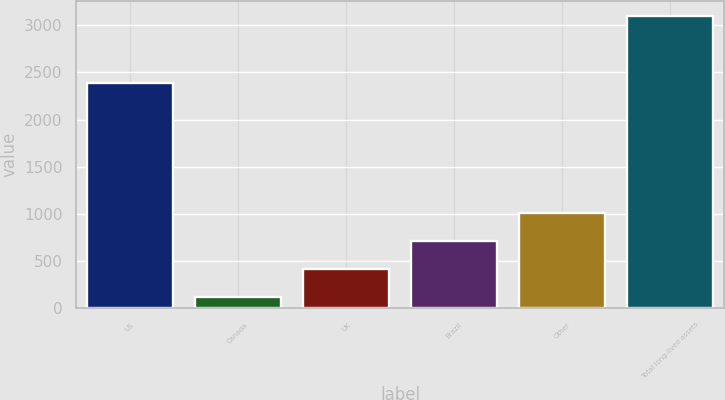Convert chart. <chart><loc_0><loc_0><loc_500><loc_500><bar_chart><fcel>US<fcel>Canada<fcel>UK<fcel>Brazil<fcel>Other<fcel>Total long-lived assets<nl><fcel>2384.5<fcel>119.2<fcel>417.17<fcel>715.14<fcel>1013.11<fcel>3098.9<nl></chart> 